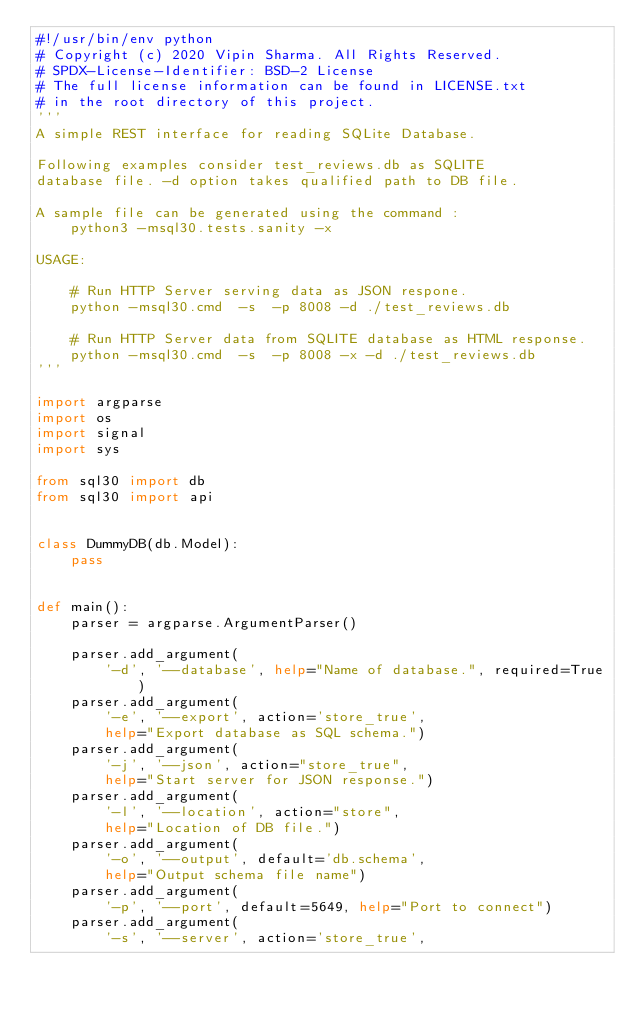<code> <loc_0><loc_0><loc_500><loc_500><_Python_>#!/usr/bin/env python
# Copyright (c) 2020 Vipin Sharma. All Rights Reserved.
# SPDX-License-Identifier: BSD-2 License
# The full license information can be found in LICENSE.txt
# in the root directory of this project.
'''
A simple REST interface for reading SQLite Database.

Following examples consider test_reviews.db as SQLITE
database file. -d option takes qualified path to DB file.

A sample file can be generated using the command :
    python3 -msql30.tests.sanity -x

USAGE:

    # Run HTTP Server serving data as JSON respone.
    python -msql30.cmd  -s  -p 8008 -d ./test_reviews.db

    # Run HTTP Server data from SQLITE database as HTML response.
    python -msql30.cmd  -s  -p 8008 -x -d ./test_reviews.db
'''

import argparse
import os
import signal
import sys

from sql30 import db
from sql30 import api


class DummyDB(db.Model):
    pass


def main():
    parser = argparse.ArgumentParser()

    parser.add_argument(
        '-d', '--database', help="Name of database.", required=True)
    parser.add_argument(
        '-e', '--export', action='store_true',
        help="Export database as SQL schema.")
    parser.add_argument(
        '-j', '--json', action="store_true",
        help="Start server for JSON response.")
    parser.add_argument(
        '-l', '--location', action="store",
        help="Location of DB file.")
    parser.add_argument(
        '-o', '--output', default='db.schema',
        help="Output schema file name")
    parser.add_argument(
        '-p', '--port', default=5649, help="Port to connect")
    parser.add_argument(
        '-s', '--server', action='store_true',</code> 